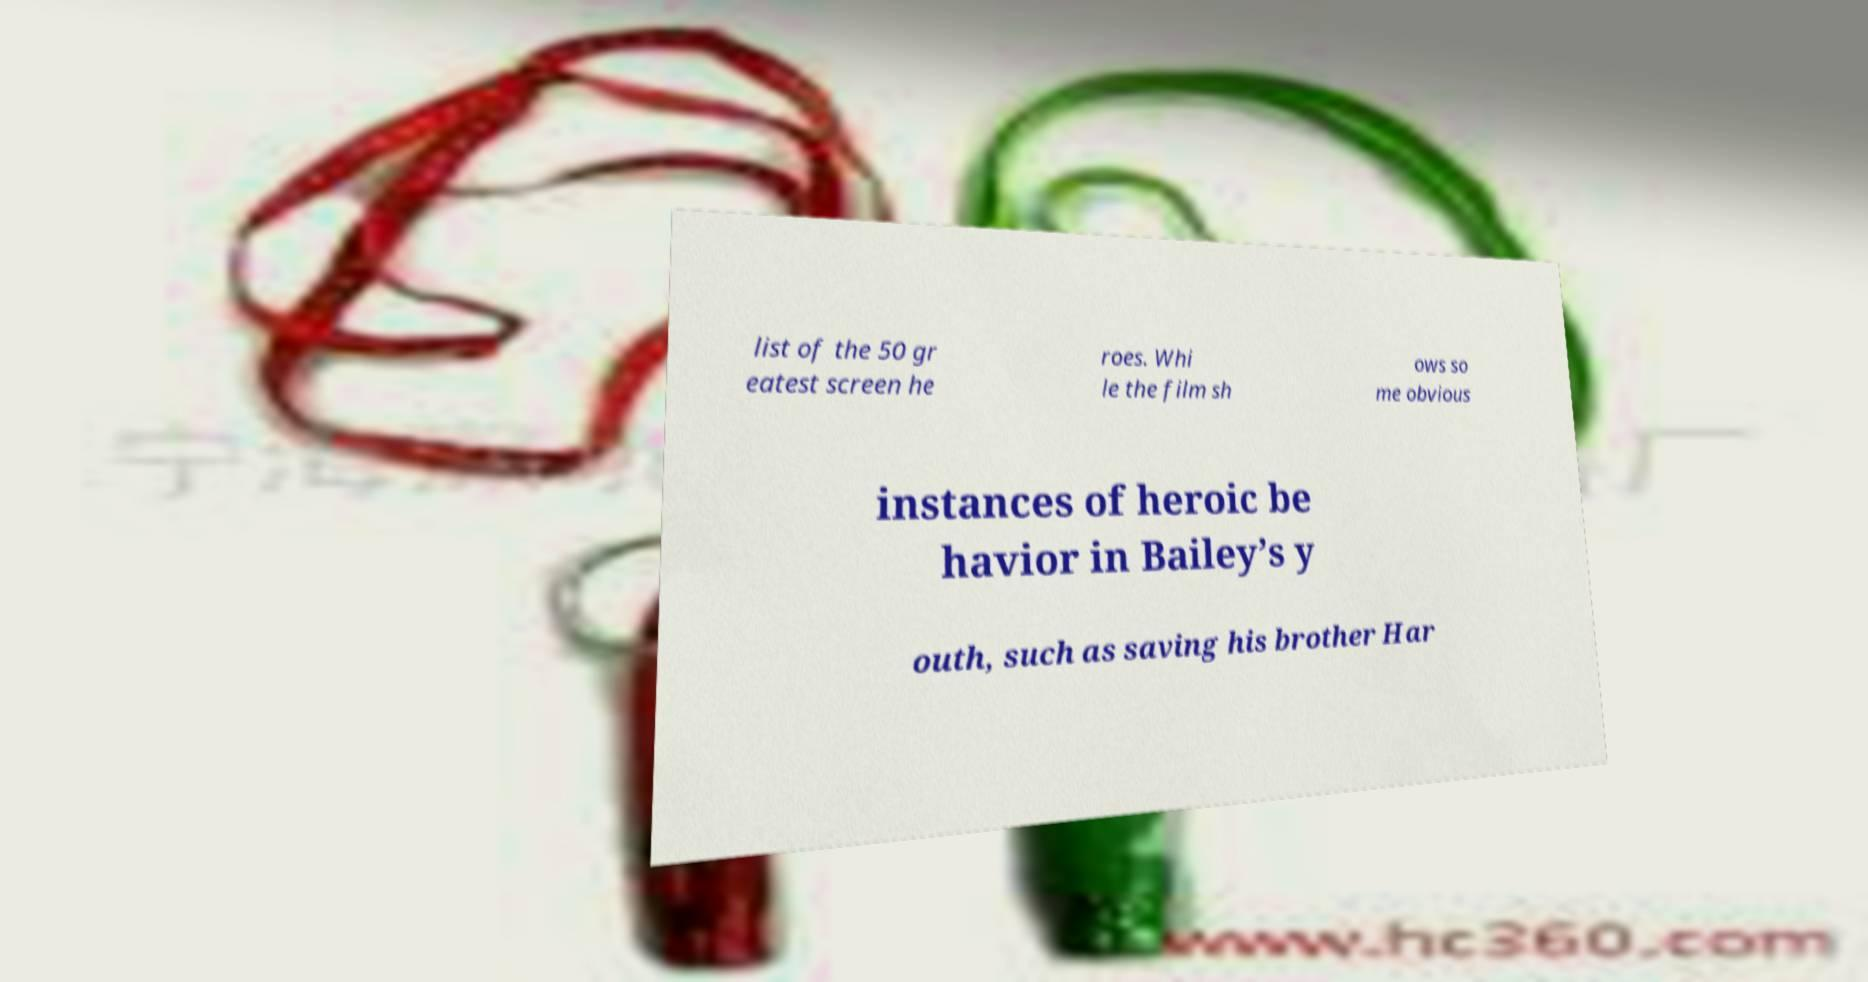Please identify and transcribe the text found in this image. list of the 50 gr eatest screen he roes. Whi le the film sh ows so me obvious instances of heroic be havior in Bailey’s y outh, such as saving his brother Har 